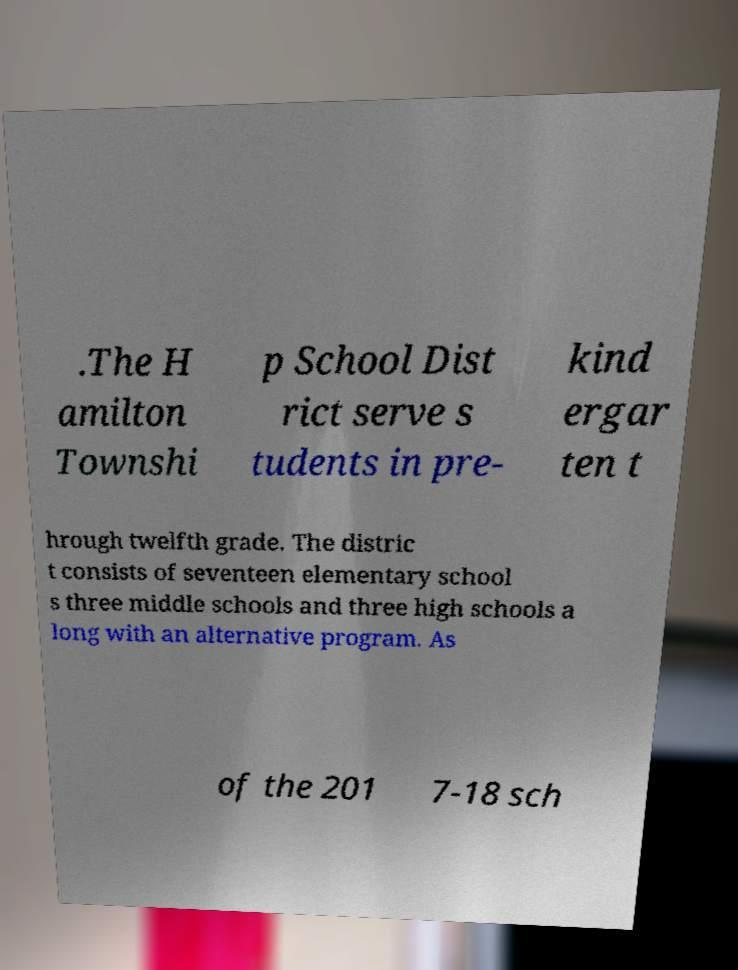What messages or text are displayed in this image? I need them in a readable, typed format. .The H amilton Townshi p School Dist rict serve s tudents in pre- kind ergar ten t hrough twelfth grade. The distric t consists of seventeen elementary school s three middle schools and three high schools a long with an alternative program. As of the 201 7-18 sch 